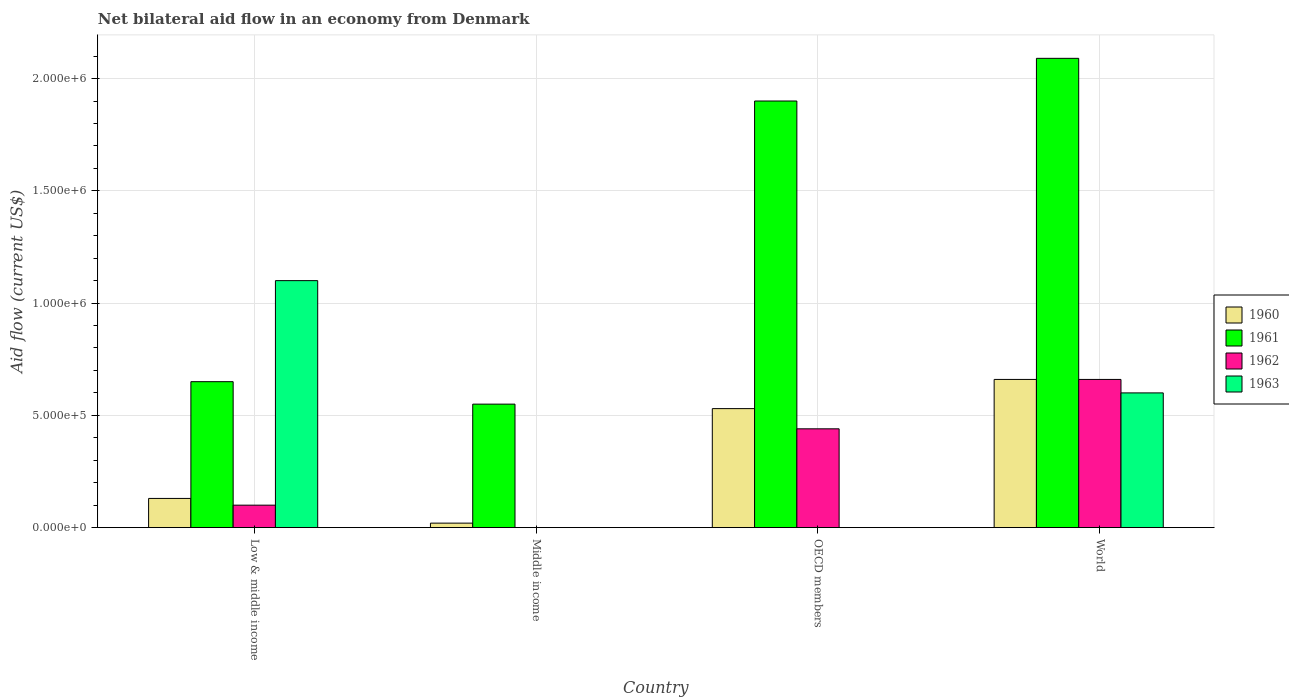How many groups of bars are there?
Provide a succinct answer. 4. Are the number of bars on each tick of the X-axis equal?
Provide a short and direct response. No. How many bars are there on the 1st tick from the left?
Ensure brevity in your answer.  4. What is the label of the 1st group of bars from the left?
Keep it short and to the point. Low & middle income. In how many cases, is the number of bars for a given country not equal to the number of legend labels?
Offer a very short reply. 2. What is the net bilateral aid flow in 1963 in World?
Make the answer very short. 6.00e+05. Across all countries, what is the maximum net bilateral aid flow in 1963?
Give a very brief answer. 1.10e+06. In which country was the net bilateral aid flow in 1960 maximum?
Provide a short and direct response. World. What is the total net bilateral aid flow in 1961 in the graph?
Keep it short and to the point. 5.19e+06. What is the difference between the net bilateral aid flow in 1961 in Middle income and that in OECD members?
Keep it short and to the point. -1.35e+06. What is the difference between the net bilateral aid flow in 1961 in Middle income and the net bilateral aid flow in 1963 in OECD members?
Keep it short and to the point. 5.50e+05. What is the average net bilateral aid flow in 1960 per country?
Provide a short and direct response. 3.35e+05. What is the difference between the net bilateral aid flow of/in 1961 and net bilateral aid flow of/in 1963 in Low & middle income?
Make the answer very short. -4.50e+05. What is the ratio of the net bilateral aid flow in 1960 in OECD members to that in World?
Your answer should be compact. 0.8. Is the net bilateral aid flow in 1962 in OECD members less than that in World?
Make the answer very short. Yes. What is the difference between the highest and the second highest net bilateral aid flow in 1960?
Provide a short and direct response. 1.30e+05. What is the difference between the highest and the lowest net bilateral aid flow in 1963?
Make the answer very short. 1.10e+06. In how many countries, is the net bilateral aid flow in 1961 greater than the average net bilateral aid flow in 1961 taken over all countries?
Your response must be concise. 2. Is it the case that in every country, the sum of the net bilateral aid flow in 1963 and net bilateral aid flow in 1960 is greater than the net bilateral aid flow in 1961?
Ensure brevity in your answer.  No. How many bars are there?
Your response must be concise. 13. How many countries are there in the graph?
Your answer should be very brief. 4. What is the difference between two consecutive major ticks on the Y-axis?
Ensure brevity in your answer.  5.00e+05. Does the graph contain any zero values?
Your answer should be very brief. Yes. Where does the legend appear in the graph?
Ensure brevity in your answer.  Center right. How many legend labels are there?
Make the answer very short. 4. How are the legend labels stacked?
Ensure brevity in your answer.  Vertical. What is the title of the graph?
Provide a short and direct response. Net bilateral aid flow in an economy from Denmark. Does "1969" appear as one of the legend labels in the graph?
Your response must be concise. No. What is the Aid flow (current US$) of 1961 in Low & middle income?
Provide a short and direct response. 6.50e+05. What is the Aid flow (current US$) in 1962 in Low & middle income?
Provide a short and direct response. 1.00e+05. What is the Aid flow (current US$) of 1963 in Low & middle income?
Ensure brevity in your answer.  1.10e+06. What is the Aid flow (current US$) of 1961 in Middle income?
Give a very brief answer. 5.50e+05. What is the Aid flow (current US$) of 1960 in OECD members?
Keep it short and to the point. 5.30e+05. What is the Aid flow (current US$) in 1961 in OECD members?
Keep it short and to the point. 1.90e+06. What is the Aid flow (current US$) in 1962 in OECD members?
Your response must be concise. 4.40e+05. What is the Aid flow (current US$) in 1961 in World?
Provide a succinct answer. 2.09e+06. What is the Aid flow (current US$) of 1962 in World?
Provide a short and direct response. 6.60e+05. Across all countries, what is the maximum Aid flow (current US$) in 1961?
Your answer should be very brief. 2.09e+06. Across all countries, what is the maximum Aid flow (current US$) of 1962?
Offer a terse response. 6.60e+05. Across all countries, what is the maximum Aid flow (current US$) of 1963?
Provide a succinct answer. 1.10e+06. Across all countries, what is the minimum Aid flow (current US$) of 1961?
Keep it short and to the point. 5.50e+05. Across all countries, what is the minimum Aid flow (current US$) of 1962?
Your response must be concise. 0. What is the total Aid flow (current US$) in 1960 in the graph?
Give a very brief answer. 1.34e+06. What is the total Aid flow (current US$) in 1961 in the graph?
Your answer should be compact. 5.19e+06. What is the total Aid flow (current US$) of 1962 in the graph?
Your answer should be compact. 1.20e+06. What is the total Aid flow (current US$) of 1963 in the graph?
Ensure brevity in your answer.  1.70e+06. What is the difference between the Aid flow (current US$) in 1961 in Low & middle income and that in Middle income?
Provide a short and direct response. 1.00e+05. What is the difference between the Aid flow (current US$) in 1960 in Low & middle income and that in OECD members?
Offer a terse response. -4.00e+05. What is the difference between the Aid flow (current US$) of 1961 in Low & middle income and that in OECD members?
Keep it short and to the point. -1.25e+06. What is the difference between the Aid flow (current US$) of 1960 in Low & middle income and that in World?
Keep it short and to the point. -5.30e+05. What is the difference between the Aid flow (current US$) in 1961 in Low & middle income and that in World?
Ensure brevity in your answer.  -1.44e+06. What is the difference between the Aid flow (current US$) in 1962 in Low & middle income and that in World?
Your answer should be compact. -5.60e+05. What is the difference between the Aid flow (current US$) of 1960 in Middle income and that in OECD members?
Your answer should be very brief. -5.10e+05. What is the difference between the Aid flow (current US$) in 1961 in Middle income and that in OECD members?
Make the answer very short. -1.35e+06. What is the difference between the Aid flow (current US$) of 1960 in Middle income and that in World?
Your response must be concise. -6.40e+05. What is the difference between the Aid flow (current US$) of 1961 in Middle income and that in World?
Ensure brevity in your answer.  -1.54e+06. What is the difference between the Aid flow (current US$) in 1960 in OECD members and that in World?
Your answer should be very brief. -1.30e+05. What is the difference between the Aid flow (current US$) of 1960 in Low & middle income and the Aid flow (current US$) of 1961 in Middle income?
Give a very brief answer. -4.20e+05. What is the difference between the Aid flow (current US$) of 1960 in Low & middle income and the Aid flow (current US$) of 1961 in OECD members?
Give a very brief answer. -1.77e+06. What is the difference between the Aid flow (current US$) of 1960 in Low & middle income and the Aid flow (current US$) of 1962 in OECD members?
Your response must be concise. -3.10e+05. What is the difference between the Aid flow (current US$) in 1961 in Low & middle income and the Aid flow (current US$) in 1962 in OECD members?
Offer a very short reply. 2.10e+05. What is the difference between the Aid flow (current US$) of 1960 in Low & middle income and the Aid flow (current US$) of 1961 in World?
Your response must be concise. -1.96e+06. What is the difference between the Aid flow (current US$) of 1960 in Low & middle income and the Aid flow (current US$) of 1962 in World?
Your answer should be compact. -5.30e+05. What is the difference between the Aid flow (current US$) of 1960 in Low & middle income and the Aid flow (current US$) of 1963 in World?
Your answer should be compact. -4.70e+05. What is the difference between the Aid flow (current US$) in 1962 in Low & middle income and the Aid flow (current US$) in 1963 in World?
Keep it short and to the point. -5.00e+05. What is the difference between the Aid flow (current US$) of 1960 in Middle income and the Aid flow (current US$) of 1961 in OECD members?
Provide a succinct answer. -1.88e+06. What is the difference between the Aid flow (current US$) of 1960 in Middle income and the Aid flow (current US$) of 1962 in OECD members?
Your answer should be compact. -4.20e+05. What is the difference between the Aid flow (current US$) of 1961 in Middle income and the Aid flow (current US$) of 1962 in OECD members?
Give a very brief answer. 1.10e+05. What is the difference between the Aid flow (current US$) of 1960 in Middle income and the Aid flow (current US$) of 1961 in World?
Ensure brevity in your answer.  -2.07e+06. What is the difference between the Aid flow (current US$) of 1960 in Middle income and the Aid flow (current US$) of 1962 in World?
Offer a very short reply. -6.40e+05. What is the difference between the Aid flow (current US$) in 1960 in Middle income and the Aid flow (current US$) in 1963 in World?
Keep it short and to the point. -5.80e+05. What is the difference between the Aid flow (current US$) in 1961 in Middle income and the Aid flow (current US$) in 1963 in World?
Provide a succinct answer. -5.00e+04. What is the difference between the Aid flow (current US$) in 1960 in OECD members and the Aid flow (current US$) in 1961 in World?
Your answer should be very brief. -1.56e+06. What is the difference between the Aid flow (current US$) of 1960 in OECD members and the Aid flow (current US$) of 1962 in World?
Your answer should be compact. -1.30e+05. What is the difference between the Aid flow (current US$) of 1960 in OECD members and the Aid flow (current US$) of 1963 in World?
Keep it short and to the point. -7.00e+04. What is the difference between the Aid flow (current US$) of 1961 in OECD members and the Aid flow (current US$) of 1962 in World?
Offer a very short reply. 1.24e+06. What is the difference between the Aid flow (current US$) in 1961 in OECD members and the Aid flow (current US$) in 1963 in World?
Keep it short and to the point. 1.30e+06. What is the average Aid flow (current US$) of 1960 per country?
Your response must be concise. 3.35e+05. What is the average Aid flow (current US$) of 1961 per country?
Provide a succinct answer. 1.30e+06. What is the average Aid flow (current US$) of 1962 per country?
Ensure brevity in your answer.  3.00e+05. What is the average Aid flow (current US$) in 1963 per country?
Provide a succinct answer. 4.25e+05. What is the difference between the Aid flow (current US$) in 1960 and Aid flow (current US$) in 1961 in Low & middle income?
Your answer should be compact. -5.20e+05. What is the difference between the Aid flow (current US$) of 1960 and Aid flow (current US$) of 1962 in Low & middle income?
Ensure brevity in your answer.  3.00e+04. What is the difference between the Aid flow (current US$) of 1960 and Aid flow (current US$) of 1963 in Low & middle income?
Give a very brief answer. -9.70e+05. What is the difference between the Aid flow (current US$) of 1961 and Aid flow (current US$) of 1963 in Low & middle income?
Make the answer very short. -4.50e+05. What is the difference between the Aid flow (current US$) of 1960 and Aid flow (current US$) of 1961 in Middle income?
Make the answer very short. -5.30e+05. What is the difference between the Aid flow (current US$) in 1960 and Aid flow (current US$) in 1961 in OECD members?
Ensure brevity in your answer.  -1.37e+06. What is the difference between the Aid flow (current US$) in 1961 and Aid flow (current US$) in 1962 in OECD members?
Your response must be concise. 1.46e+06. What is the difference between the Aid flow (current US$) in 1960 and Aid flow (current US$) in 1961 in World?
Offer a very short reply. -1.43e+06. What is the difference between the Aid flow (current US$) in 1960 and Aid flow (current US$) in 1962 in World?
Your response must be concise. 0. What is the difference between the Aid flow (current US$) of 1960 and Aid flow (current US$) of 1963 in World?
Keep it short and to the point. 6.00e+04. What is the difference between the Aid flow (current US$) in 1961 and Aid flow (current US$) in 1962 in World?
Provide a short and direct response. 1.43e+06. What is the difference between the Aid flow (current US$) of 1961 and Aid flow (current US$) of 1963 in World?
Your answer should be very brief. 1.49e+06. What is the difference between the Aid flow (current US$) of 1962 and Aid flow (current US$) of 1963 in World?
Your answer should be compact. 6.00e+04. What is the ratio of the Aid flow (current US$) of 1960 in Low & middle income to that in Middle income?
Your answer should be very brief. 6.5. What is the ratio of the Aid flow (current US$) in 1961 in Low & middle income to that in Middle income?
Your answer should be compact. 1.18. What is the ratio of the Aid flow (current US$) of 1960 in Low & middle income to that in OECD members?
Give a very brief answer. 0.25. What is the ratio of the Aid flow (current US$) in 1961 in Low & middle income to that in OECD members?
Give a very brief answer. 0.34. What is the ratio of the Aid flow (current US$) in 1962 in Low & middle income to that in OECD members?
Offer a terse response. 0.23. What is the ratio of the Aid flow (current US$) of 1960 in Low & middle income to that in World?
Make the answer very short. 0.2. What is the ratio of the Aid flow (current US$) in 1961 in Low & middle income to that in World?
Give a very brief answer. 0.31. What is the ratio of the Aid flow (current US$) of 1962 in Low & middle income to that in World?
Make the answer very short. 0.15. What is the ratio of the Aid flow (current US$) of 1963 in Low & middle income to that in World?
Make the answer very short. 1.83. What is the ratio of the Aid flow (current US$) of 1960 in Middle income to that in OECD members?
Offer a very short reply. 0.04. What is the ratio of the Aid flow (current US$) of 1961 in Middle income to that in OECD members?
Your response must be concise. 0.29. What is the ratio of the Aid flow (current US$) in 1960 in Middle income to that in World?
Your answer should be compact. 0.03. What is the ratio of the Aid flow (current US$) in 1961 in Middle income to that in World?
Provide a short and direct response. 0.26. What is the ratio of the Aid flow (current US$) of 1960 in OECD members to that in World?
Give a very brief answer. 0.8. What is the ratio of the Aid flow (current US$) in 1961 in OECD members to that in World?
Your answer should be very brief. 0.91. What is the difference between the highest and the second highest Aid flow (current US$) of 1961?
Ensure brevity in your answer.  1.90e+05. What is the difference between the highest and the lowest Aid flow (current US$) of 1960?
Provide a short and direct response. 6.40e+05. What is the difference between the highest and the lowest Aid flow (current US$) in 1961?
Provide a succinct answer. 1.54e+06. What is the difference between the highest and the lowest Aid flow (current US$) in 1963?
Offer a very short reply. 1.10e+06. 